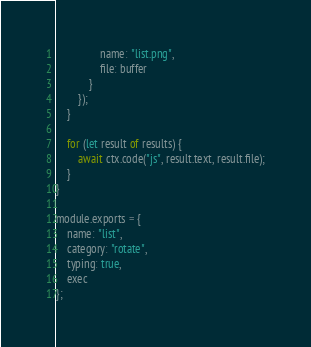<code> <loc_0><loc_0><loc_500><loc_500><_JavaScript_>                name: "list.png",
                file: buffer
            }
        });
    }

    for (let result of results) {
        await ctx.code("js", result.text, result.file);
    }
}

module.exports = {
    name: "list",
    category: "rotate",
    typing: true,
    exec
};
</code> 